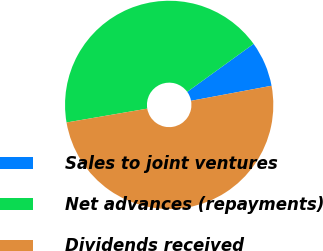Convert chart. <chart><loc_0><loc_0><loc_500><loc_500><pie_chart><fcel>Sales to joint ventures<fcel>Net advances (repayments)<fcel>Dividends received<nl><fcel>7.02%<fcel>42.74%<fcel>50.23%<nl></chart> 